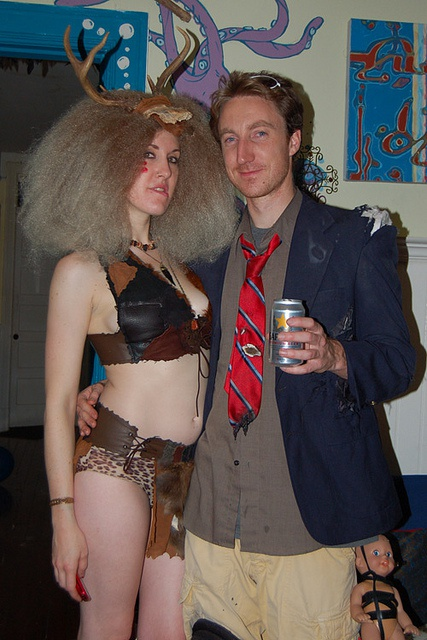Describe the objects in this image and their specific colors. I can see people in gray, black, tan, and brown tones, people in gray, darkgray, and maroon tones, tie in gray, brown, maroon, and black tones, and couch in gray, black, navy, and maroon tones in this image. 